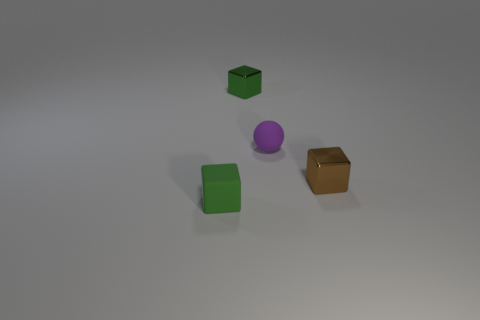How many matte blocks have the same color as the small matte ball?
Your answer should be compact. 0. There is a small matte thing that is the same shape as the small green metal object; what is its color?
Keep it short and to the point. Green. There is a small object that is both on the left side of the tiny rubber ball and on the right side of the green matte cube; what is its shape?
Give a very brief answer. Cube. Are there more small cubes than green blocks?
Ensure brevity in your answer.  Yes. What is the material of the brown cube?
Keep it short and to the point. Metal. What is the size of the other metal thing that is the same shape as the brown thing?
Your response must be concise. Small. There is a block that is behind the purple matte sphere; is there a small block behind it?
Keep it short and to the point. No. Is the color of the rubber ball the same as the small matte block?
Keep it short and to the point. No. How many other things are there of the same shape as the small brown shiny thing?
Provide a short and direct response. 2. Are there more blocks that are right of the matte cube than purple spheres right of the small brown metal object?
Your answer should be compact. Yes. 